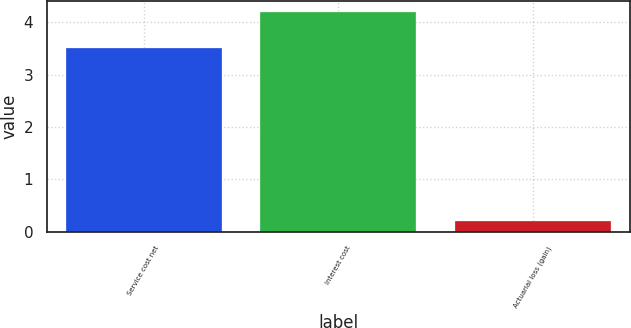Convert chart. <chart><loc_0><loc_0><loc_500><loc_500><bar_chart><fcel>Service cost net<fcel>Interest cost<fcel>Actuarial loss (gain)<nl><fcel>3.5<fcel>4.2<fcel>0.2<nl></chart> 